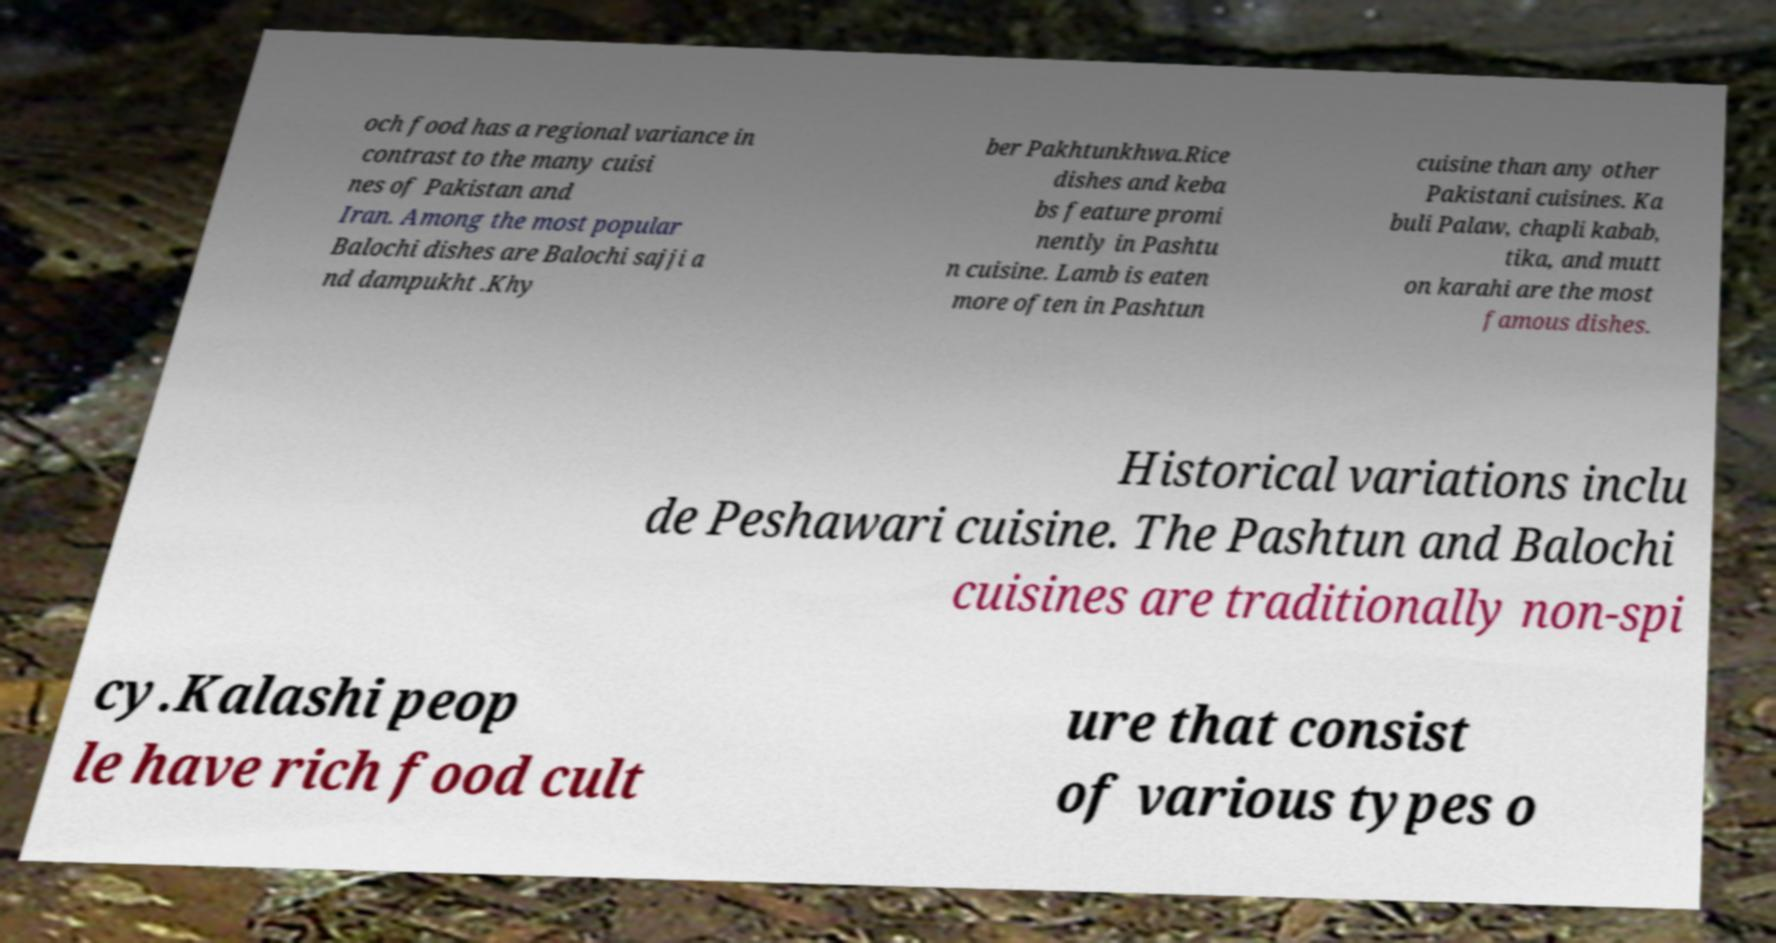Please read and relay the text visible in this image. What does it say? och food has a regional variance in contrast to the many cuisi nes of Pakistan and Iran. Among the most popular Balochi dishes are Balochi sajji a nd dampukht .Khy ber Pakhtunkhwa.Rice dishes and keba bs feature promi nently in Pashtu n cuisine. Lamb is eaten more often in Pashtun cuisine than any other Pakistani cuisines. Ka buli Palaw, chapli kabab, tika, and mutt on karahi are the most famous dishes. Historical variations inclu de Peshawari cuisine. The Pashtun and Balochi cuisines are traditionally non-spi cy.Kalashi peop le have rich food cult ure that consist of various types o 